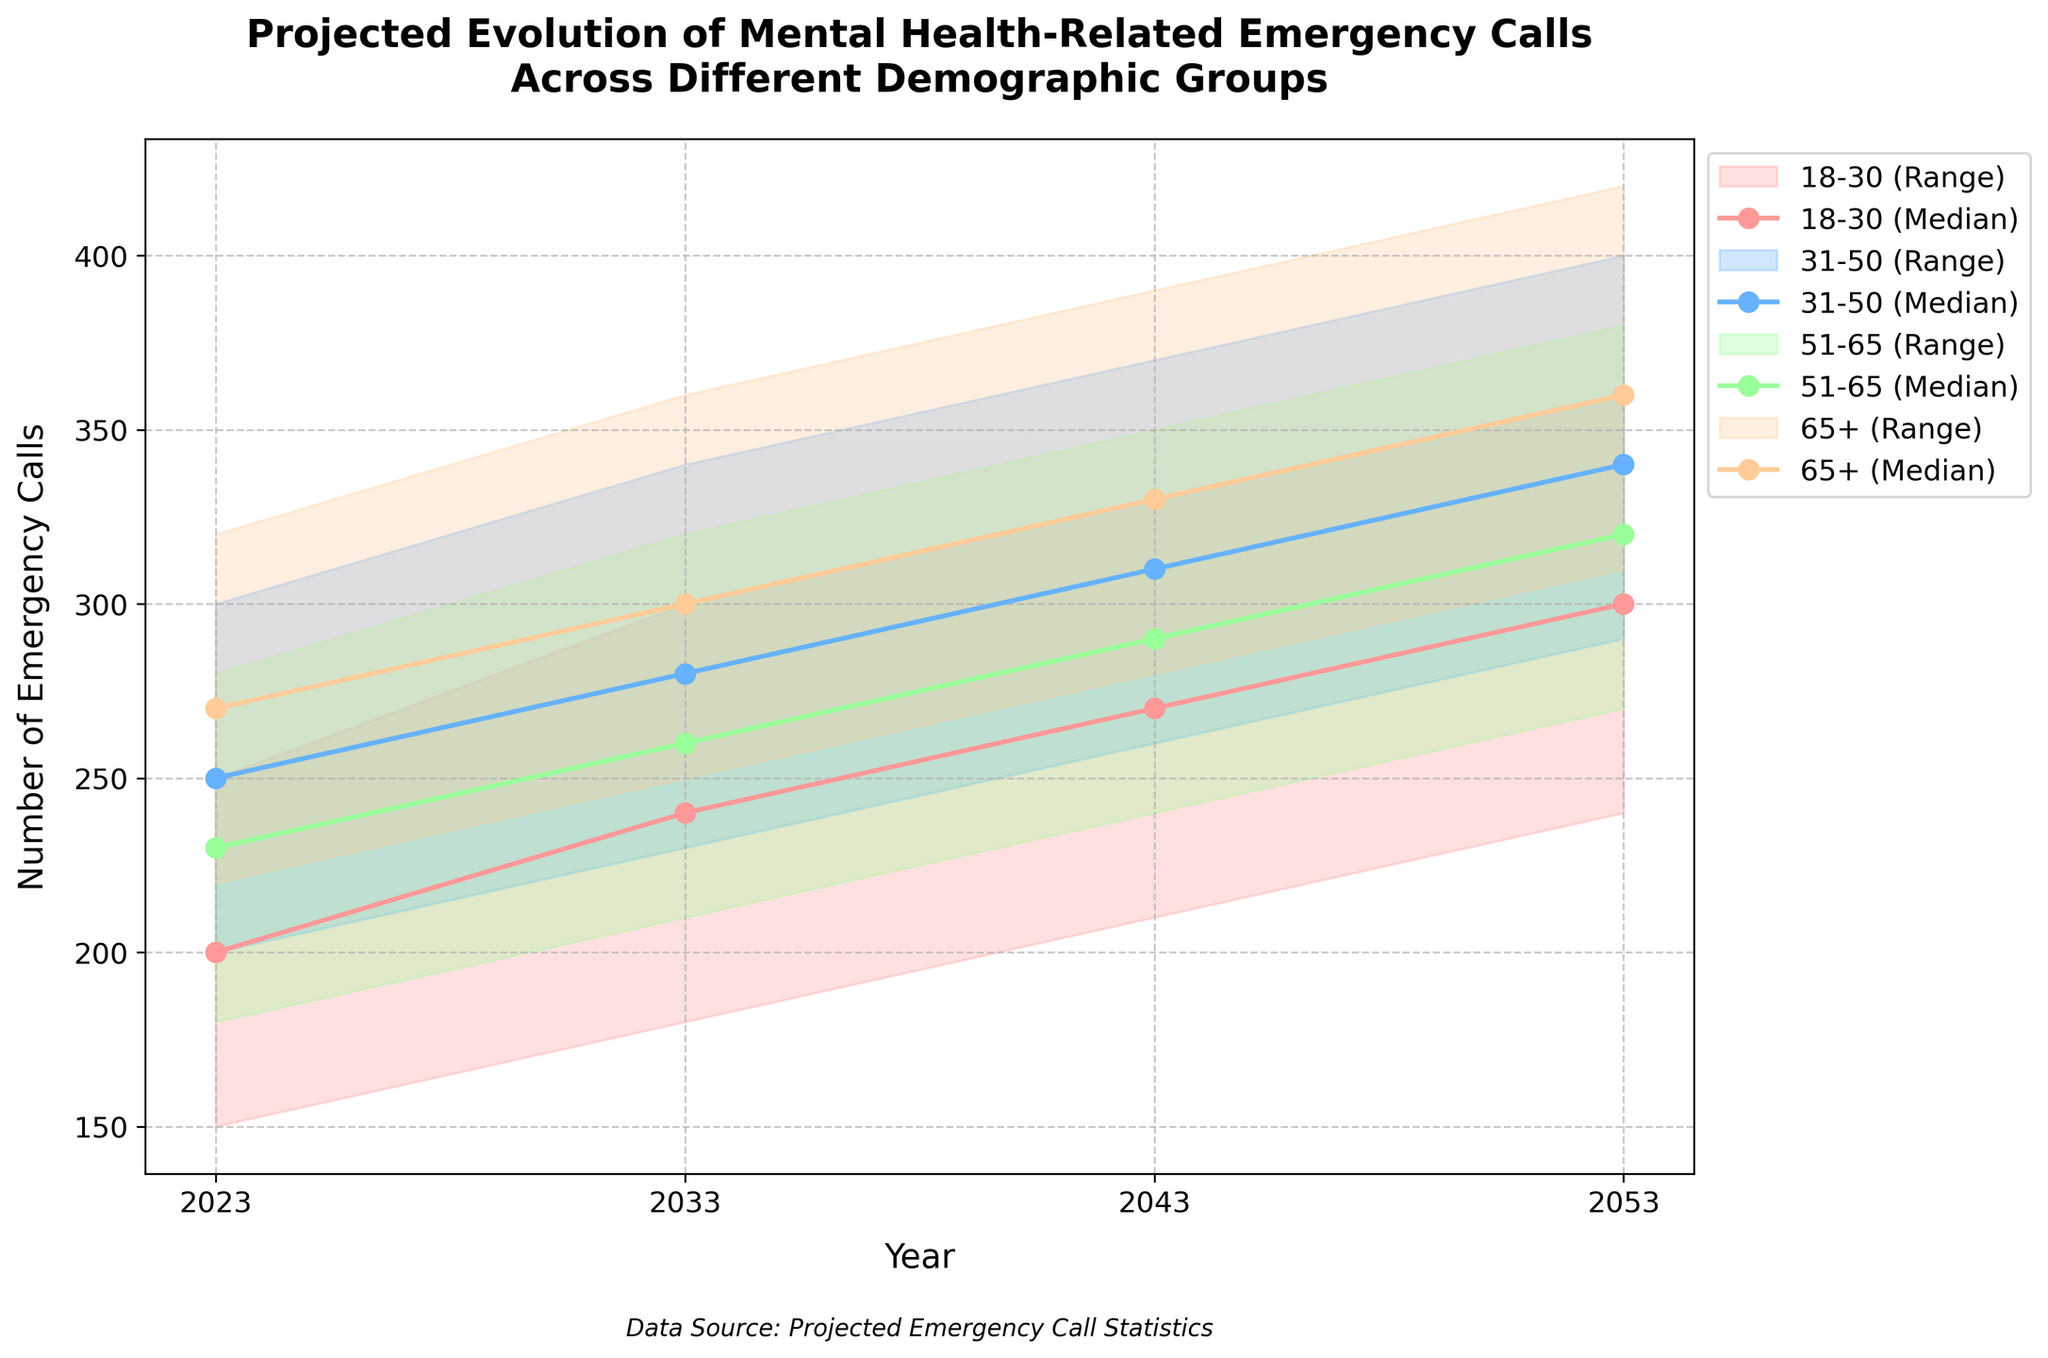What is the title of the plot? The title of the plot appears at the top and states the focus of the visual representation. In this case, the title is "Projected Evolution of Mental Health-Related Emergency Calls Across Different Demographic Groups".
Answer: Projected Evolution of Mental Health-Related Emergency Calls Across Different Demographic Groups How many age groups are represented in the plot? By counting the unique color-coded lines and shaded areas, we can determine the number of age groups represented. There are four color groups: 18-30, 31-50, 51-65, and 65+.
Answer: 4 What is the upper bound for the 31-50 age group in the year 2043? Locate the 31-50 age group data for the year 2043 and check the value at the upper bound. It is marked at 370.
Answer: 370 Which age group has the highest projected median number of emergency calls in 2053? To find this, compare the median lines for all age groups in the year 2053. The 65+ age group has the highest projected median at 360.
Answer: 65+ What is the trend for the 18-30 age group's median number of calls from 2023 to 2053? By following the median line for the 18-30 age group across the years, it's clear that the median number of calls increases from 200 in 2023 to 300 in 2053.
Answer: Increasing How does the range (distance between upper bound and lower bound) change for the 51-65 age group from 2023 to 2053? Calculate the range as Upper Bound minus Lower Bound for 2023 (280-180) and for 2053 (380-270). The range increases from 100 in 2023 to 110 in 2053.
Answer: Increasing Which year shows the smallest range in calls for the 65+ age group? To find the smallest range, we calculate the difference between the upper and lower bounds for the 65+ age group for each year: 2023 (100), 2033 (110), 2043 (110), 2053 (110). The smallest range is in 2023.
Answer: 2023 By how much does the median number of calls for the 31-50 age group increase from 2023 to 2043? Find the median number of calls in 2023 (250) and 2043 (310) for 31-50 age group, then calculate the difference: 310 - 250 = 60.
Answer: 60 Which age group experiences the largest increase in the upper bound of calls from 2023 to 2053? Compare the upper bound values in 2023 and 2053 across all age groups: 18-30 (250 to 360), 31-50 (300 to 400), 51-65 (280 to 380), 65+ (320 to 420). The 65+ age group shows the largest increase (100).
Answer: 65+ For which two demographic groups does the median number of emergency calls converge closest in 2053? Check the median numbers in 2053: 18-30 (300), 31-50 (340), 51-65 (320), 65+ (360). The closest medians are 51-65 and 31-50 with a difference of 20.
Answer: 51-65 and 31-50 